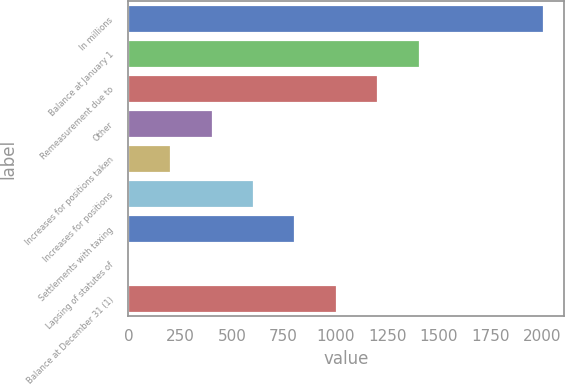<chart> <loc_0><loc_0><loc_500><loc_500><bar_chart><fcel>In millions<fcel>Balance at January 1<fcel>Remeasurement due to<fcel>Other<fcel>Increases for positions taken<fcel>Increases for positions<fcel>Settlements with taxing<fcel>Lapsing of statutes of<fcel>Balance at December 31 (1)<nl><fcel>2007<fcel>1406.88<fcel>1206.84<fcel>406.68<fcel>206.64<fcel>606.72<fcel>806.76<fcel>6.6<fcel>1006.8<nl></chart> 